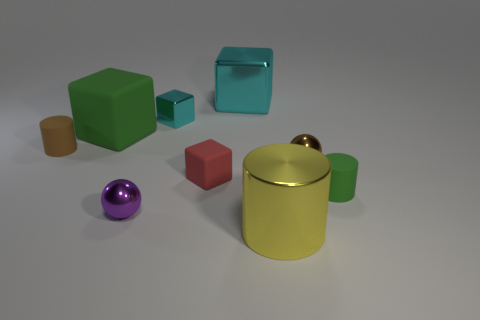Subtract all brown cylinders. How many cylinders are left? 2 Add 5 purple cubes. How many purple cubes exist? 5 Subtract all red blocks. How many blocks are left? 3 Subtract 1 cyan cubes. How many objects are left? 8 Subtract all cylinders. How many objects are left? 6 Subtract 1 balls. How many balls are left? 1 Subtract all cyan cylinders. Subtract all purple spheres. How many cylinders are left? 3 Subtract all purple cubes. How many purple balls are left? 1 Subtract all tiny rubber blocks. Subtract all large things. How many objects are left? 5 Add 6 brown matte things. How many brown matte things are left? 7 